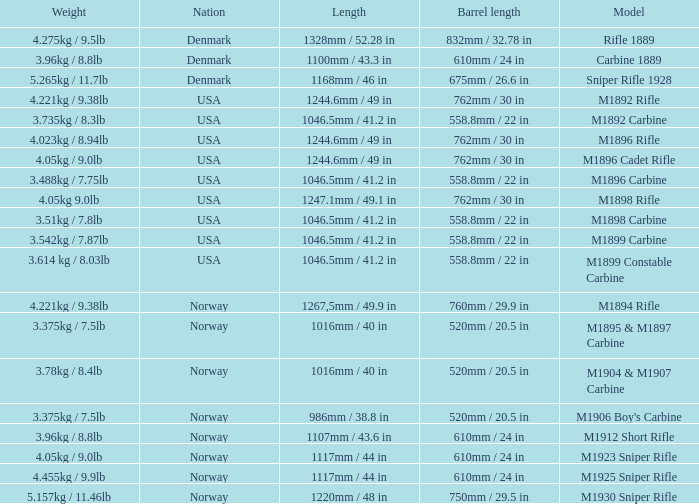What is Nation, when Model is M1895 & M1897 Carbine? Norway. 